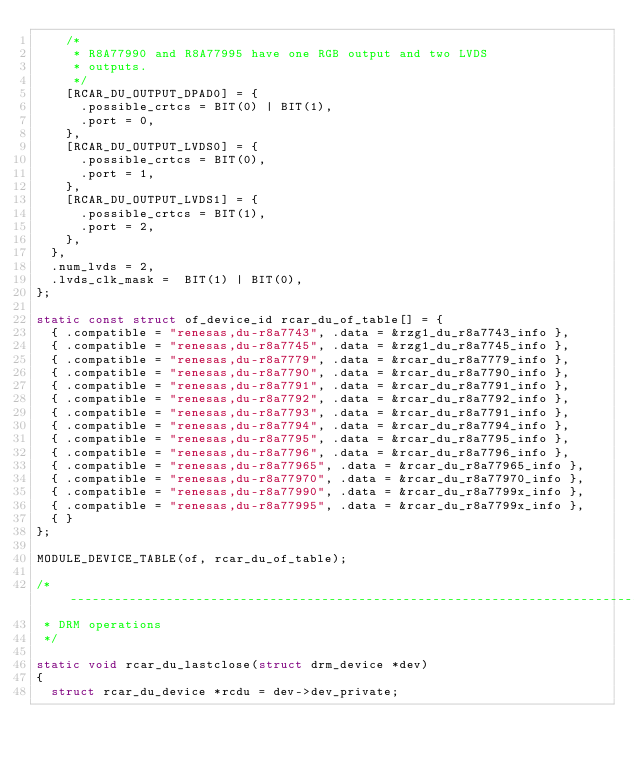<code> <loc_0><loc_0><loc_500><loc_500><_C_>		/*
		 * R8A77990 and R8A77995 have one RGB output and two LVDS
		 * outputs.
		 */
		[RCAR_DU_OUTPUT_DPAD0] = {
			.possible_crtcs = BIT(0) | BIT(1),
			.port = 0,
		},
		[RCAR_DU_OUTPUT_LVDS0] = {
			.possible_crtcs = BIT(0),
			.port = 1,
		},
		[RCAR_DU_OUTPUT_LVDS1] = {
			.possible_crtcs = BIT(1),
			.port = 2,
		},
	},
	.num_lvds = 2,
	.lvds_clk_mask =  BIT(1) | BIT(0),
};

static const struct of_device_id rcar_du_of_table[] = {
	{ .compatible = "renesas,du-r8a7743", .data = &rzg1_du_r8a7743_info },
	{ .compatible = "renesas,du-r8a7745", .data = &rzg1_du_r8a7745_info },
	{ .compatible = "renesas,du-r8a7779", .data = &rcar_du_r8a7779_info },
	{ .compatible = "renesas,du-r8a7790", .data = &rcar_du_r8a7790_info },
	{ .compatible = "renesas,du-r8a7791", .data = &rcar_du_r8a7791_info },
	{ .compatible = "renesas,du-r8a7792", .data = &rcar_du_r8a7792_info },
	{ .compatible = "renesas,du-r8a7793", .data = &rcar_du_r8a7791_info },
	{ .compatible = "renesas,du-r8a7794", .data = &rcar_du_r8a7794_info },
	{ .compatible = "renesas,du-r8a7795", .data = &rcar_du_r8a7795_info },
	{ .compatible = "renesas,du-r8a7796", .data = &rcar_du_r8a7796_info },
	{ .compatible = "renesas,du-r8a77965", .data = &rcar_du_r8a77965_info },
	{ .compatible = "renesas,du-r8a77970", .data = &rcar_du_r8a77970_info },
	{ .compatible = "renesas,du-r8a77990", .data = &rcar_du_r8a7799x_info },
	{ .compatible = "renesas,du-r8a77995", .data = &rcar_du_r8a7799x_info },
	{ }
};

MODULE_DEVICE_TABLE(of, rcar_du_of_table);

/* -----------------------------------------------------------------------------
 * DRM operations
 */

static void rcar_du_lastclose(struct drm_device *dev)
{
	struct rcar_du_device *rcdu = dev->dev_private;
</code> 